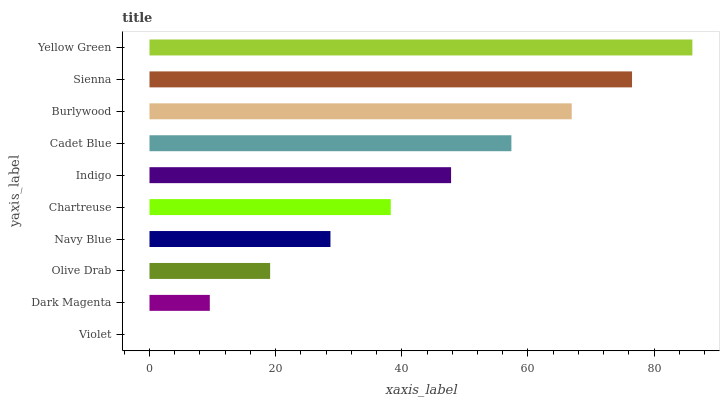Is Violet the minimum?
Answer yes or no. Yes. Is Yellow Green the maximum?
Answer yes or no. Yes. Is Dark Magenta the minimum?
Answer yes or no. No. Is Dark Magenta the maximum?
Answer yes or no. No. Is Dark Magenta greater than Violet?
Answer yes or no. Yes. Is Violet less than Dark Magenta?
Answer yes or no. Yes. Is Violet greater than Dark Magenta?
Answer yes or no. No. Is Dark Magenta less than Violet?
Answer yes or no. No. Is Indigo the high median?
Answer yes or no. Yes. Is Chartreuse the low median?
Answer yes or no. Yes. Is Yellow Green the high median?
Answer yes or no. No. Is Sienna the low median?
Answer yes or no. No. 